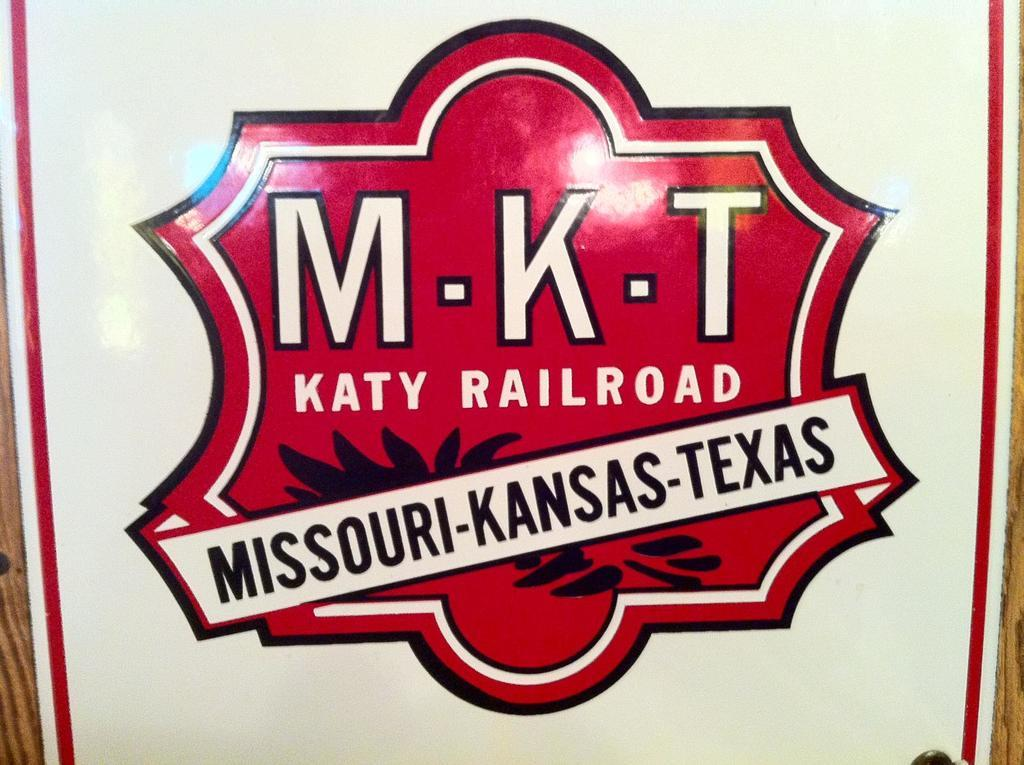<image>
Give a short and clear explanation of the subsequent image. The states listed are Missouri-Kansas-Texas on the poster 